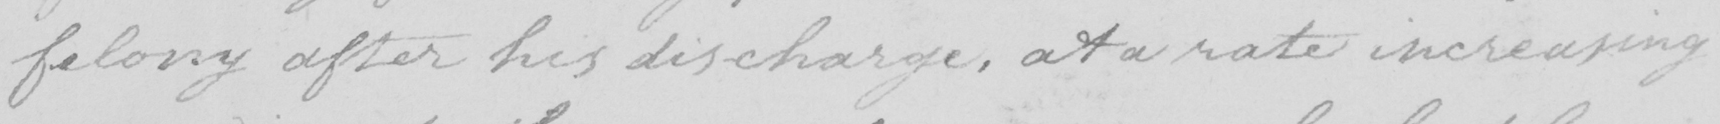Transcribe the text shown in this historical manuscript line. felony after his discharge , at a rate increasing 